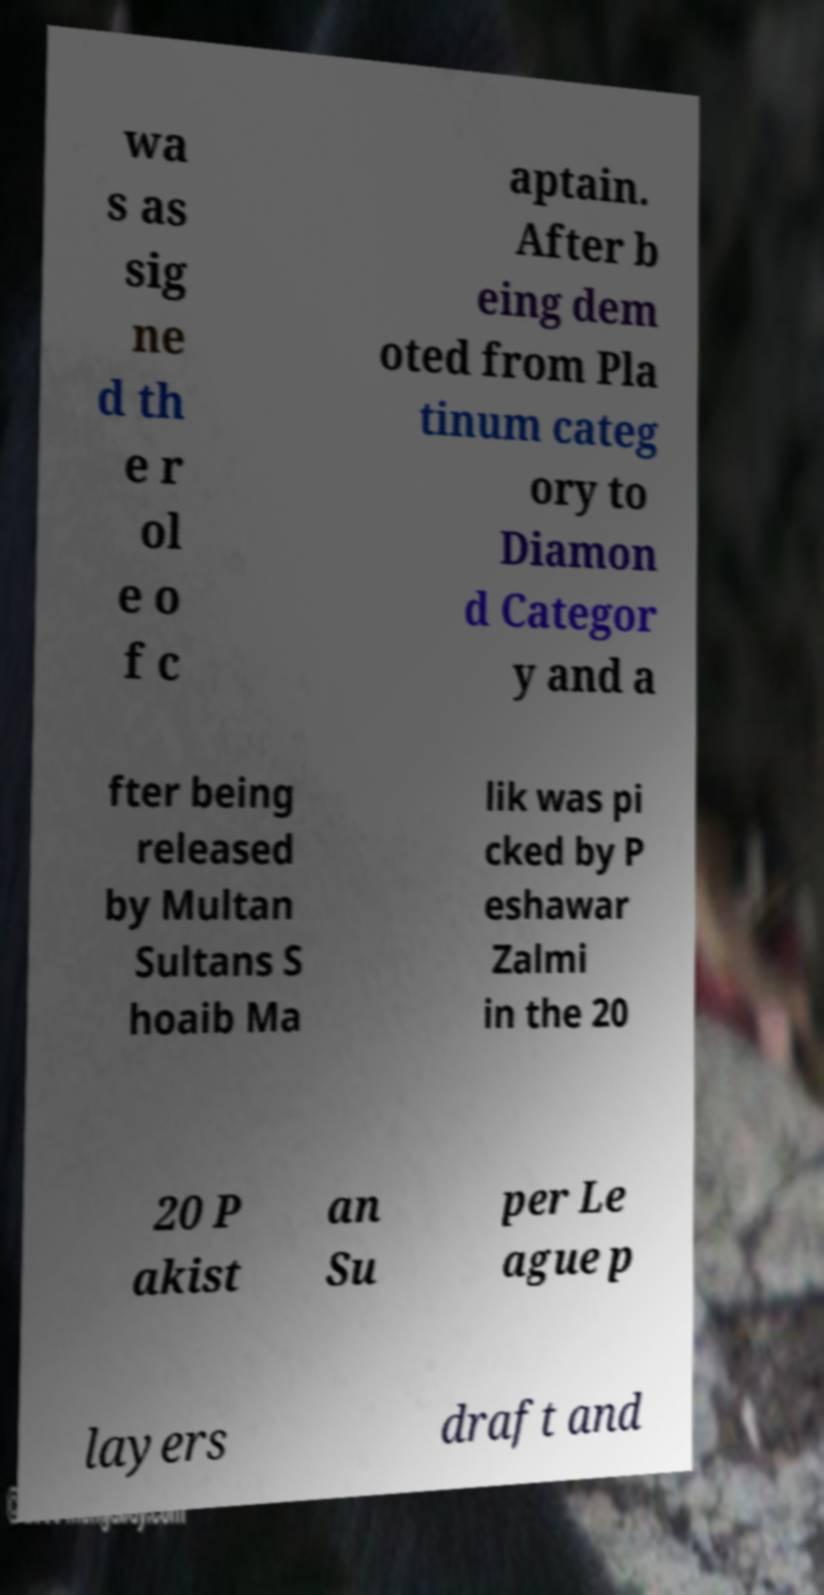Could you assist in decoding the text presented in this image and type it out clearly? wa s as sig ne d th e r ol e o f c aptain. After b eing dem oted from Pla tinum categ ory to Diamon d Categor y and a fter being released by Multan Sultans S hoaib Ma lik was pi cked by P eshawar Zalmi in the 20 20 P akist an Su per Le ague p layers draft and 